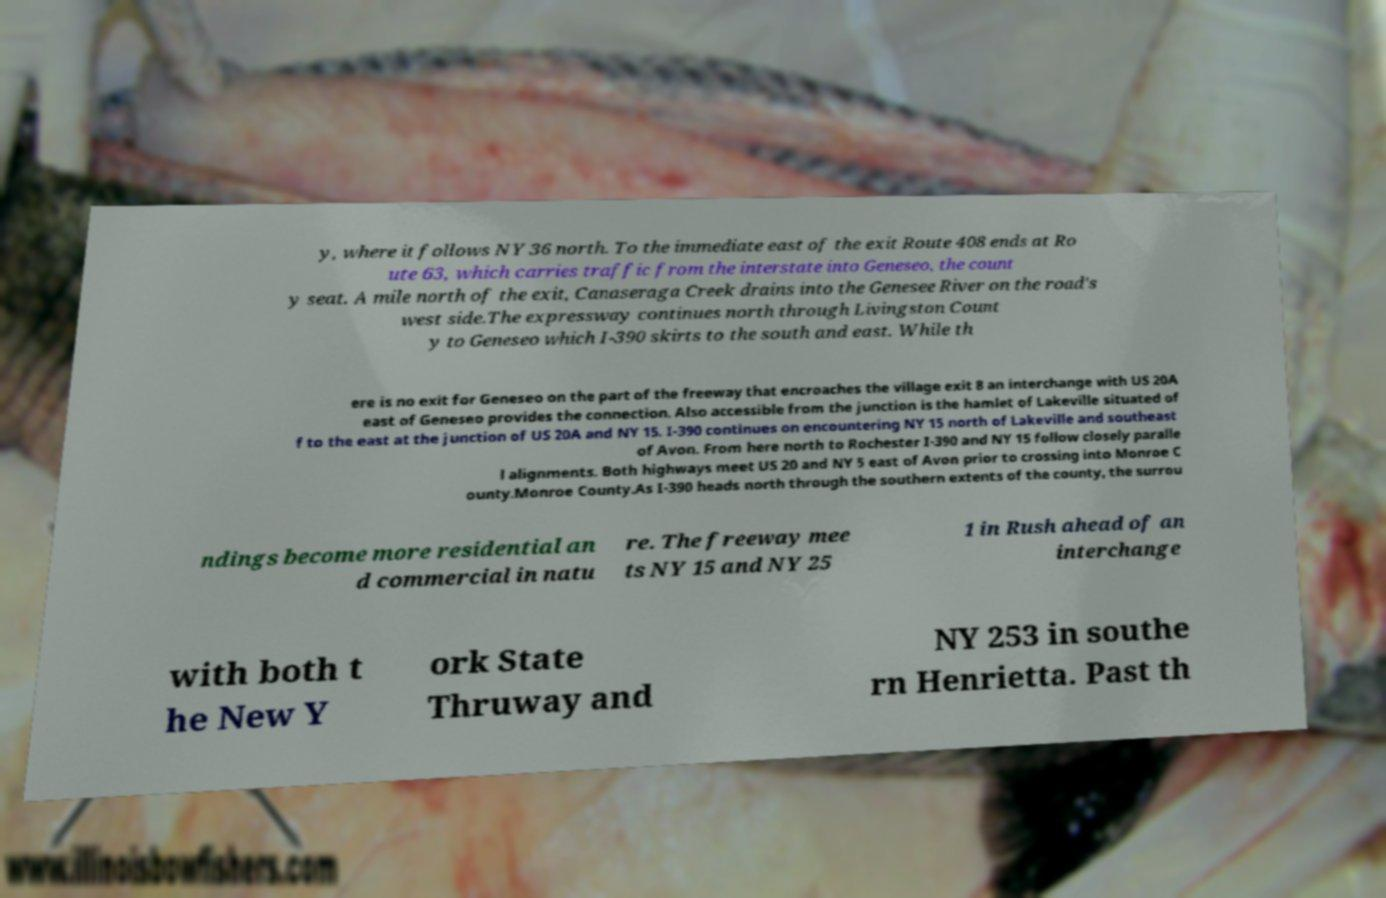For documentation purposes, I need the text within this image transcribed. Could you provide that? y, where it follows NY 36 north. To the immediate east of the exit Route 408 ends at Ro ute 63, which carries traffic from the interstate into Geneseo, the count y seat. A mile north of the exit, Canaseraga Creek drains into the Genesee River on the road's west side.The expressway continues north through Livingston Count y to Geneseo which I-390 skirts to the south and east. While th ere is no exit for Geneseo on the part of the freeway that encroaches the village exit 8 an interchange with US 20A east of Geneseo provides the connection. Also accessible from the junction is the hamlet of Lakeville situated of f to the east at the junction of US 20A and NY 15. I-390 continues on encountering NY 15 north of Lakeville and southeast of Avon. From here north to Rochester I-390 and NY 15 follow closely paralle l alignments. Both highways meet US 20 and NY 5 east of Avon prior to crossing into Monroe C ounty.Monroe County.As I-390 heads north through the southern extents of the county, the surrou ndings become more residential an d commercial in natu re. The freeway mee ts NY 15 and NY 25 1 in Rush ahead of an interchange with both t he New Y ork State Thruway and NY 253 in southe rn Henrietta. Past th 